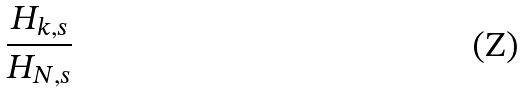<formula> <loc_0><loc_0><loc_500><loc_500>\frac { H _ { k , s } } { H _ { N , s } }</formula> 